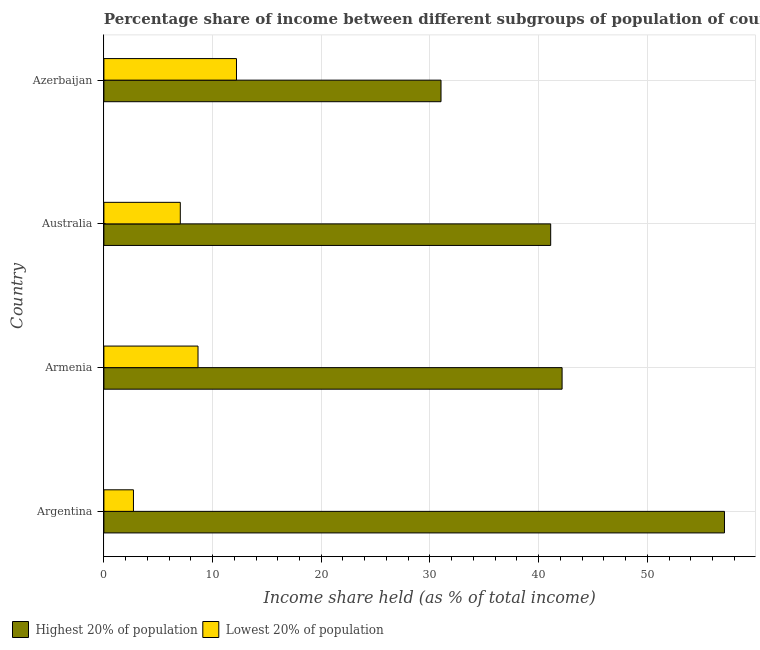How many groups of bars are there?
Your answer should be very brief. 4. What is the label of the 1st group of bars from the top?
Your answer should be very brief. Azerbaijan. What is the income share held by highest 20% of the population in Armenia?
Your answer should be very brief. 42.16. Across all countries, what is the maximum income share held by highest 20% of the population?
Make the answer very short. 57.1. Across all countries, what is the minimum income share held by lowest 20% of the population?
Your answer should be compact. 2.72. In which country was the income share held by lowest 20% of the population maximum?
Provide a succinct answer. Azerbaijan. What is the total income share held by highest 20% of the population in the graph?
Offer a very short reply. 171.39. What is the difference between the income share held by lowest 20% of the population in Australia and that in Azerbaijan?
Your response must be concise. -5.17. What is the difference between the income share held by lowest 20% of the population in Argentina and the income share held by highest 20% of the population in Armenia?
Provide a succinct answer. -39.44. What is the average income share held by highest 20% of the population per country?
Provide a short and direct response. 42.85. What is the difference between the income share held by lowest 20% of the population and income share held by highest 20% of the population in Australia?
Your response must be concise. -34.08. What is the ratio of the income share held by highest 20% of the population in Australia to that in Azerbaijan?
Your answer should be compact. 1.32. Is the income share held by lowest 20% of the population in Armenia less than that in Azerbaijan?
Provide a short and direct response. Yes. Is the difference between the income share held by highest 20% of the population in Australia and Azerbaijan greater than the difference between the income share held by lowest 20% of the population in Australia and Azerbaijan?
Provide a short and direct response. Yes. What is the difference between the highest and the second highest income share held by highest 20% of the population?
Your answer should be compact. 14.94. What is the difference between the highest and the lowest income share held by lowest 20% of the population?
Give a very brief answer. 9.48. In how many countries, is the income share held by highest 20% of the population greater than the average income share held by highest 20% of the population taken over all countries?
Ensure brevity in your answer.  1. Is the sum of the income share held by lowest 20% of the population in Australia and Azerbaijan greater than the maximum income share held by highest 20% of the population across all countries?
Offer a very short reply. No. What does the 1st bar from the top in Armenia represents?
Offer a terse response. Lowest 20% of population. What does the 2nd bar from the bottom in Armenia represents?
Your answer should be very brief. Lowest 20% of population. How many bars are there?
Your answer should be compact. 8. Are all the bars in the graph horizontal?
Ensure brevity in your answer.  Yes. Does the graph contain any zero values?
Make the answer very short. No. Where does the legend appear in the graph?
Provide a succinct answer. Bottom left. How are the legend labels stacked?
Your response must be concise. Horizontal. What is the title of the graph?
Offer a very short reply. Percentage share of income between different subgroups of population of countries. What is the label or title of the X-axis?
Give a very brief answer. Income share held (as % of total income). What is the Income share held (as % of total income) of Highest 20% of population in Argentina?
Your answer should be very brief. 57.1. What is the Income share held (as % of total income) in Lowest 20% of population in Argentina?
Provide a succinct answer. 2.72. What is the Income share held (as % of total income) in Highest 20% of population in Armenia?
Keep it short and to the point. 42.16. What is the Income share held (as % of total income) in Lowest 20% of population in Armenia?
Provide a succinct answer. 8.66. What is the Income share held (as % of total income) in Highest 20% of population in Australia?
Your answer should be very brief. 41.11. What is the Income share held (as % of total income) in Lowest 20% of population in Australia?
Offer a terse response. 7.03. What is the Income share held (as % of total income) in Highest 20% of population in Azerbaijan?
Your response must be concise. 31.02. What is the Income share held (as % of total income) of Lowest 20% of population in Azerbaijan?
Keep it short and to the point. 12.2. Across all countries, what is the maximum Income share held (as % of total income) in Highest 20% of population?
Offer a very short reply. 57.1. Across all countries, what is the minimum Income share held (as % of total income) in Highest 20% of population?
Offer a terse response. 31.02. Across all countries, what is the minimum Income share held (as % of total income) in Lowest 20% of population?
Give a very brief answer. 2.72. What is the total Income share held (as % of total income) in Highest 20% of population in the graph?
Your response must be concise. 171.39. What is the total Income share held (as % of total income) of Lowest 20% of population in the graph?
Your response must be concise. 30.61. What is the difference between the Income share held (as % of total income) of Highest 20% of population in Argentina and that in Armenia?
Provide a succinct answer. 14.94. What is the difference between the Income share held (as % of total income) of Lowest 20% of population in Argentina and that in Armenia?
Provide a succinct answer. -5.94. What is the difference between the Income share held (as % of total income) of Highest 20% of population in Argentina and that in Australia?
Offer a very short reply. 15.99. What is the difference between the Income share held (as % of total income) in Lowest 20% of population in Argentina and that in Australia?
Your answer should be compact. -4.31. What is the difference between the Income share held (as % of total income) of Highest 20% of population in Argentina and that in Azerbaijan?
Provide a succinct answer. 26.08. What is the difference between the Income share held (as % of total income) of Lowest 20% of population in Argentina and that in Azerbaijan?
Your response must be concise. -9.48. What is the difference between the Income share held (as % of total income) in Lowest 20% of population in Armenia and that in Australia?
Give a very brief answer. 1.63. What is the difference between the Income share held (as % of total income) in Highest 20% of population in Armenia and that in Azerbaijan?
Ensure brevity in your answer.  11.14. What is the difference between the Income share held (as % of total income) in Lowest 20% of population in Armenia and that in Azerbaijan?
Make the answer very short. -3.54. What is the difference between the Income share held (as % of total income) in Highest 20% of population in Australia and that in Azerbaijan?
Offer a very short reply. 10.09. What is the difference between the Income share held (as % of total income) in Lowest 20% of population in Australia and that in Azerbaijan?
Provide a succinct answer. -5.17. What is the difference between the Income share held (as % of total income) of Highest 20% of population in Argentina and the Income share held (as % of total income) of Lowest 20% of population in Armenia?
Give a very brief answer. 48.44. What is the difference between the Income share held (as % of total income) in Highest 20% of population in Argentina and the Income share held (as % of total income) in Lowest 20% of population in Australia?
Provide a succinct answer. 50.07. What is the difference between the Income share held (as % of total income) in Highest 20% of population in Argentina and the Income share held (as % of total income) in Lowest 20% of population in Azerbaijan?
Give a very brief answer. 44.9. What is the difference between the Income share held (as % of total income) of Highest 20% of population in Armenia and the Income share held (as % of total income) of Lowest 20% of population in Australia?
Your response must be concise. 35.13. What is the difference between the Income share held (as % of total income) in Highest 20% of population in Armenia and the Income share held (as % of total income) in Lowest 20% of population in Azerbaijan?
Offer a terse response. 29.96. What is the difference between the Income share held (as % of total income) of Highest 20% of population in Australia and the Income share held (as % of total income) of Lowest 20% of population in Azerbaijan?
Your answer should be very brief. 28.91. What is the average Income share held (as % of total income) of Highest 20% of population per country?
Ensure brevity in your answer.  42.85. What is the average Income share held (as % of total income) in Lowest 20% of population per country?
Provide a short and direct response. 7.65. What is the difference between the Income share held (as % of total income) in Highest 20% of population and Income share held (as % of total income) in Lowest 20% of population in Argentina?
Your answer should be compact. 54.38. What is the difference between the Income share held (as % of total income) of Highest 20% of population and Income share held (as % of total income) of Lowest 20% of population in Armenia?
Keep it short and to the point. 33.5. What is the difference between the Income share held (as % of total income) of Highest 20% of population and Income share held (as % of total income) of Lowest 20% of population in Australia?
Keep it short and to the point. 34.08. What is the difference between the Income share held (as % of total income) of Highest 20% of population and Income share held (as % of total income) of Lowest 20% of population in Azerbaijan?
Provide a short and direct response. 18.82. What is the ratio of the Income share held (as % of total income) of Highest 20% of population in Argentina to that in Armenia?
Offer a terse response. 1.35. What is the ratio of the Income share held (as % of total income) of Lowest 20% of population in Argentina to that in Armenia?
Your answer should be compact. 0.31. What is the ratio of the Income share held (as % of total income) in Highest 20% of population in Argentina to that in Australia?
Offer a terse response. 1.39. What is the ratio of the Income share held (as % of total income) in Lowest 20% of population in Argentina to that in Australia?
Keep it short and to the point. 0.39. What is the ratio of the Income share held (as % of total income) in Highest 20% of population in Argentina to that in Azerbaijan?
Give a very brief answer. 1.84. What is the ratio of the Income share held (as % of total income) in Lowest 20% of population in Argentina to that in Azerbaijan?
Your response must be concise. 0.22. What is the ratio of the Income share held (as % of total income) of Highest 20% of population in Armenia to that in Australia?
Provide a short and direct response. 1.03. What is the ratio of the Income share held (as % of total income) in Lowest 20% of population in Armenia to that in Australia?
Ensure brevity in your answer.  1.23. What is the ratio of the Income share held (as % of total income) of Highest 20% of population in Armenia to that in Azerbaijan?
Your answer should be compact. 1.36. What is the ratio of the Income share held (as % of total income) of Lowest 20% of population in Armenia to that in Azerbaijan?
Provide a short and direct response. 0.71. What is the ratio of the Income share held (as % of total income) of Highest 20% of population in Australia to that in Azerbaijan?
Keep it short and to the point. 1.33. What is the ratio of the Income share held (as % of total income) of Lowest 20% of population in Australia to that in Azerbaijan?
Provide a short and direct response. 0.58. What is the difference between the highest and the second highest Income share held (as % of total income) of Highest 20% of population?
Provide a succinct answer. 14.94. What is the difference between the highest and the second highest Income share held (as % of total income) in Lowest 20% of population?
Offer a very short reply. 3.54. What is the difference between the highest and the lowest Income share held (as % of total income) in Highest 20% of population?
Offer a very short reply. 26.08. What is the difference between the highest and the lowest Income share held (as % of total income) of Lowest 20% of population?
Your answer should be compact. 9.48. 